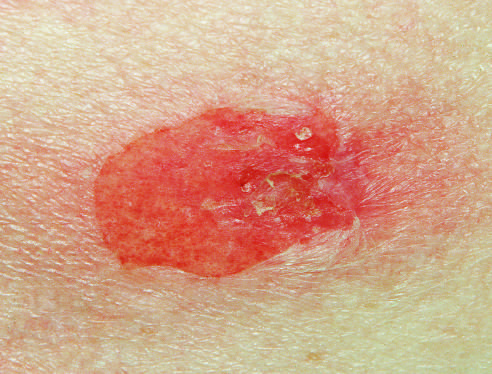s four-chamber dilation and hypertrophy seen in pemphigus vulgaris?
Answer the question using a single word or phrase. No 